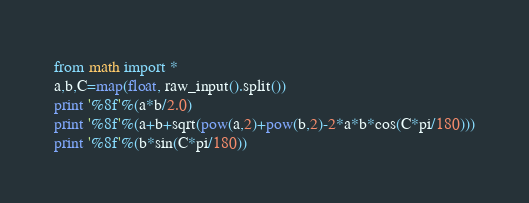<code> <loc_0><loc_0><loc_500><loc_500><_Python_>from math import *
a,b,C=map(float, raw_input().split())
print '%8f'%(a*b/2.0)
print '%8f'%(a+b+sqrt(pow(a,2)+pow(b,2)-2*a*b*cos(C*pi/180)))
print '%8f'%(b*sin(C*pi/180))</code> 